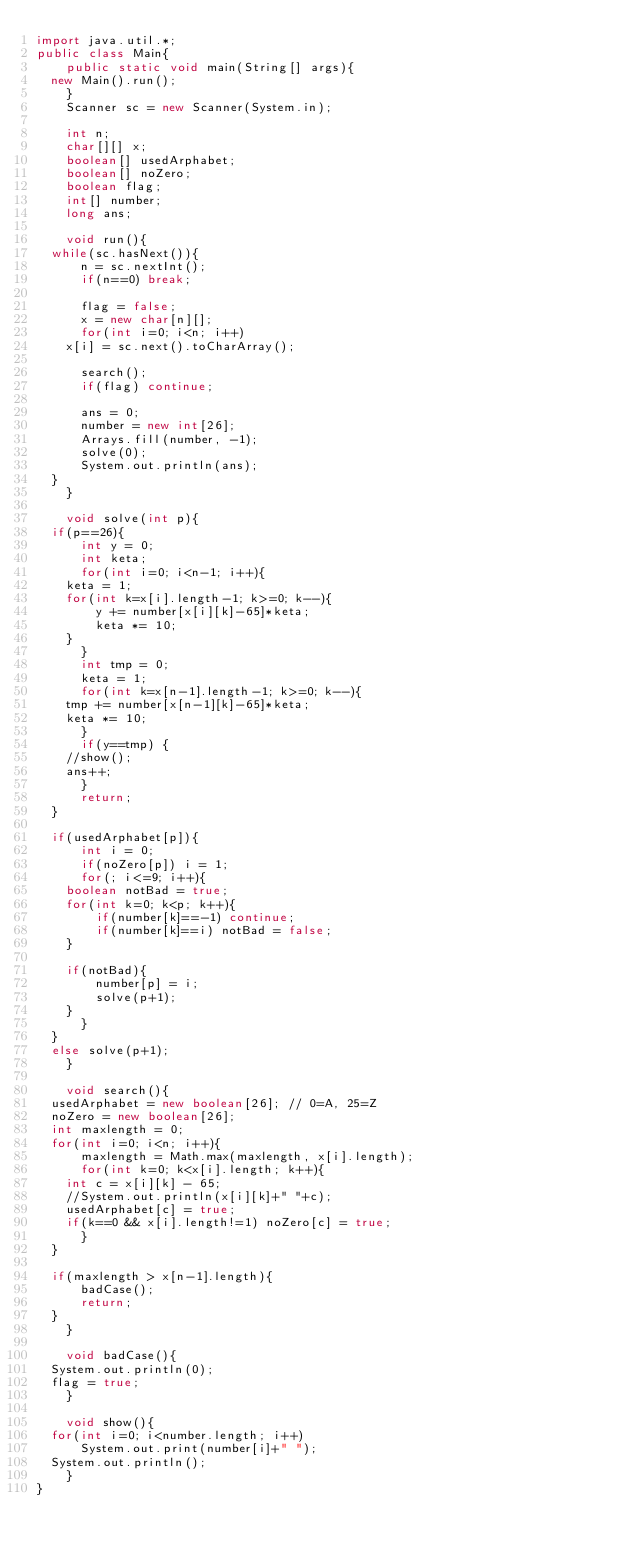Convert code to text. <code><loc_0><loc_0><loc_500><loc_500><_Java_>import java.util.*;
public class Main{
    public static void main(String[] args){
	new Main().run();
    }
    Scanner sc = new Scanner(System.in);
    
    int n;
    char[][] x;
    boolean[] usedArphabet;
    boolean[] noZero;
    boolean flag;
    int[] number;
    long ans;
    
    void run(){
	while(sc.hasNext()){
	    n = sc.nextInt();
	    if(n==0) break;
	    
	    flag = false;
	    x = new char[n][];
	    for(int i=0; i<n; i++)
		x[i] = sc.next().toCharArray();
	   
	    search();
	    if(flag) continue;

	    ans = 0;
	    number = new int[26];
	    Arrays.fill(number, -1);
	    solve(0);
	    System.out.println(ans);
	}
    }

    void solve(int p){
	if(p==26){
	    int y = 0;
	    int keta;
	    for(int i=0; i<n-1; i++){
		keta = 1;
		for(int k=x[i].length-1; k>=0; k--){
		    y += number[x[i][k]-65]*keta;
		    keta *= 10;
		}
	    }
	    int tmp = 0;
	    keta = 1;
	    for(int k=x[n-1].length-1; k>=0; k--){
		tmp += number[x[n-1][k]-65]*keta;
		keta *= 10;
	    }
	    if(y==tmp) {
		//show();
		ans++;
	    }
	    return;
	}

	if(usedArphabet[p]){
	    int i = 0;
	    if(noZero[p]) i = 1;
	    for(; i<=9; i++){
		boolean notBad = true;
		for(int k=0; k<p; k++){
		    if(number[k]==-1) continue;
		    if(number[k]==i) notBad = false;
		}

		if(notBad){
		    number[p] = i;
		    solve(p+1);
		}
	    }
	}
	else solve(p+1);
    }

    void search(){
	usedArphabet = new boolean[26]; // 0=A, 25=Z
	noZero = new boolean[26];
	int maxlength = 0;
	for(int i=0; i<n; i++){
	    maxlength = Math.max(maxlength, x[i].length);
	    for(int k=0; k<x[i].length; k++){
		int c = x[i][k] - 65;
		//System.out.println(x[i][k]+" "+c);
		usedArphabet[c] = true;
		if(k==0 && x[i].length!=1) noZero[c] = true;
	    }
	}

	if(maxlength > x[n-1].length){
	    badCase();
	    return;
	}
    }

    void badCase(){
	System.out.println(0);
	flag = true;
    }

    void show(){
	for(int i=0; i<number.length; i++)
	    System.out.print(number[i]+" ");
	System.out.println();
    }
}</code> 